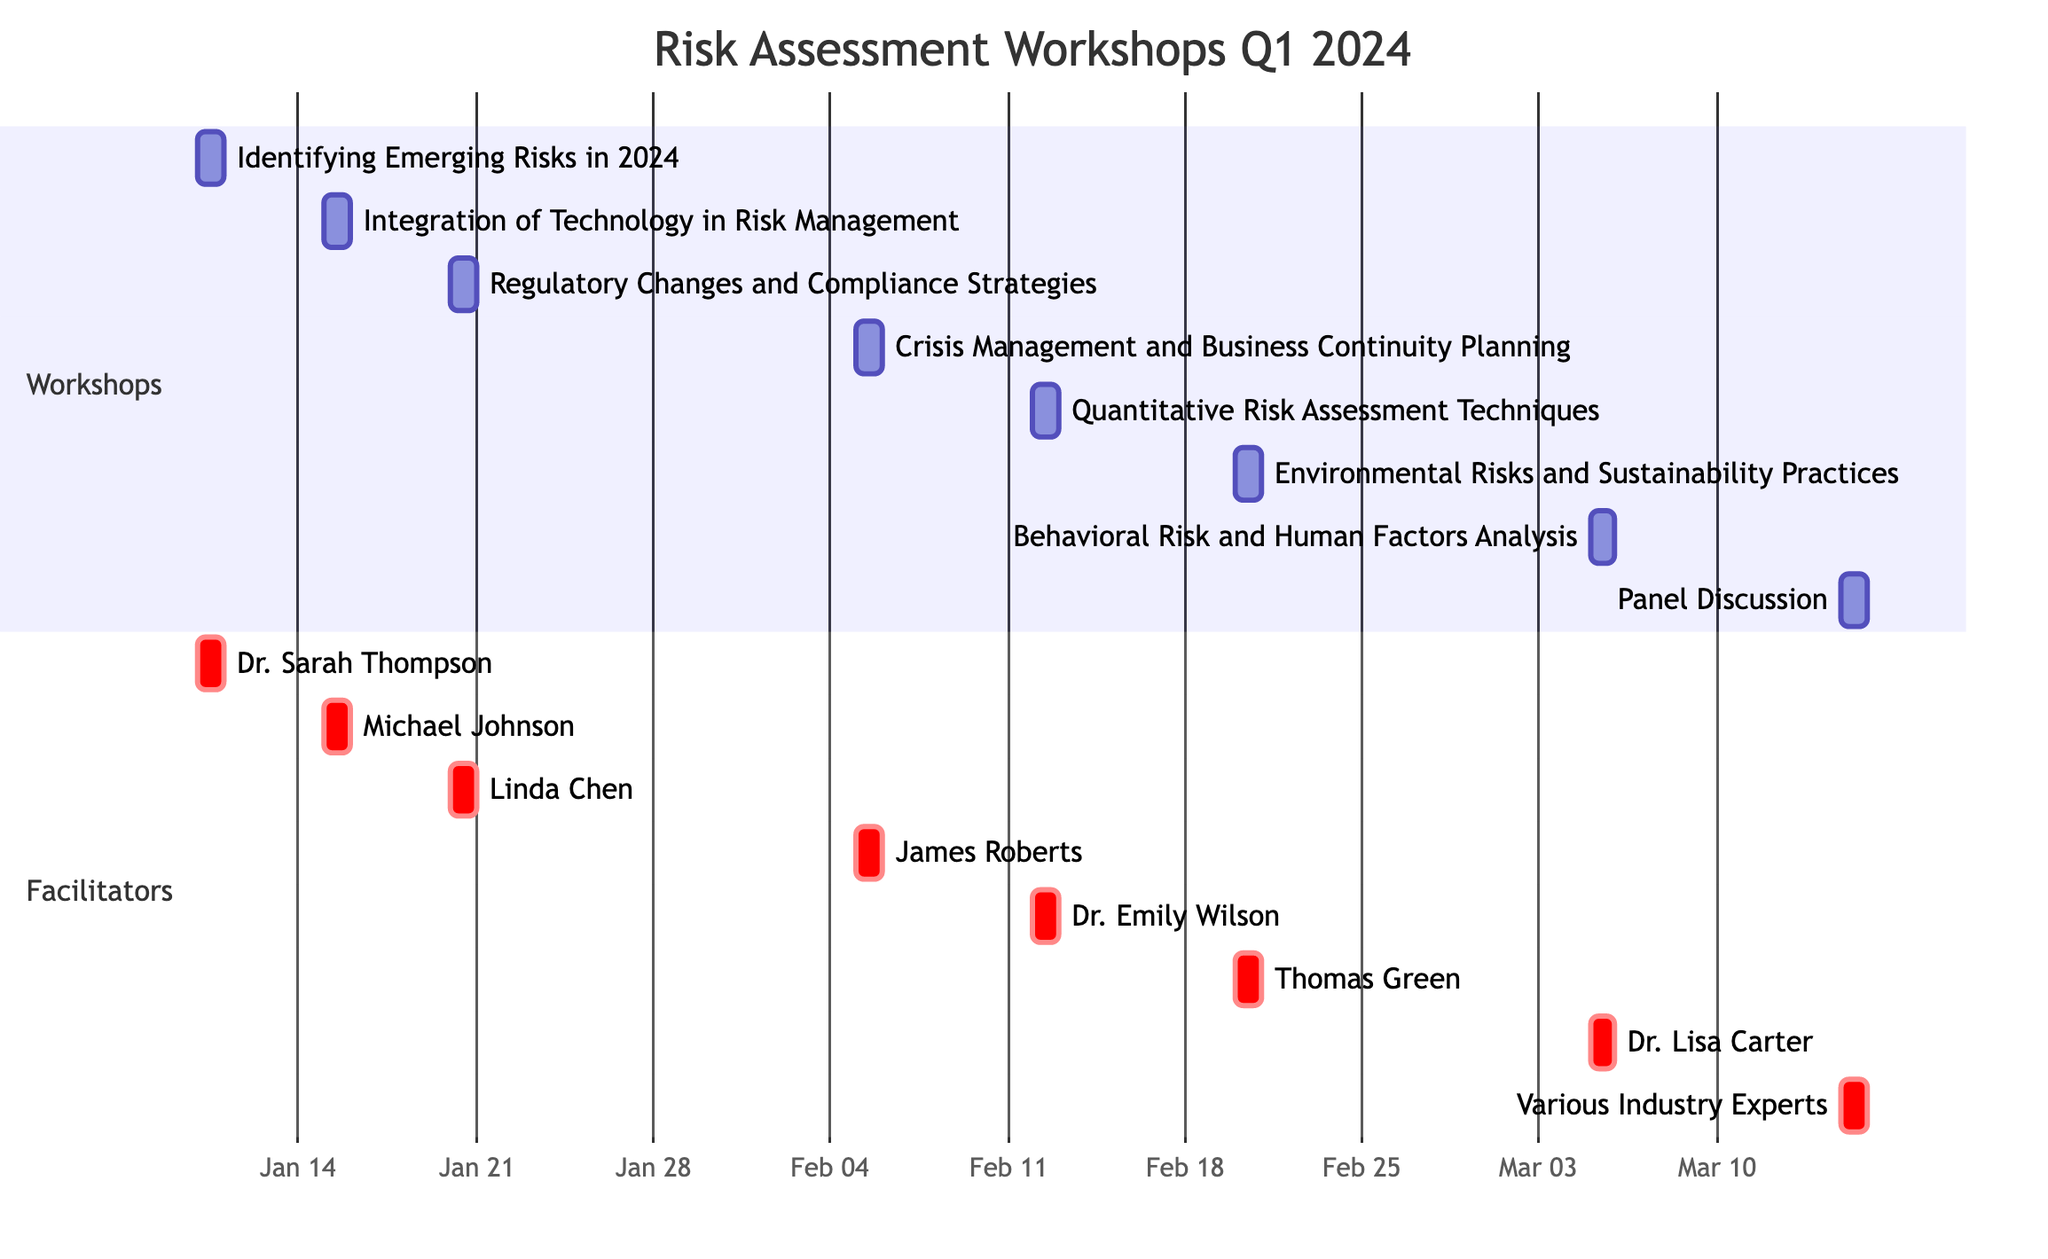What is the title of the first workshop scheduled in January? The first workshop is titled "Identifying Emerging Risks in 2024," which is on January 10th.
Answer: Identifying Emerging Risks in 2024 Who is the facilitator for the workshop on February 20? The workshop scheduled for February 20 is titled "Environmental Risks and Sustainability Practices," and it is facilitated by Thomas Green.
Answer: Thomas Green How many workshops are scheduled in March? In March, there are two workshops. The titles are "Behavioral Risk and Human Factors Analysis" on March 5th and "Panel Discussion: Future Trends in Risk Management" on March 15th.
Answer: 2 What is the start date of the workshop on quantitative risk assessment? The workshop titled "Quantitative Risk Assessment Techniques" starts on February 12, 2024.
Answer: February 12 Which facilitator is leading the workshop on crisis management? The workshop on February 5, titled "Crisis Management and Business Continuity Planning," is facilitated by James Roberts.
Answer: James Roberts How many total workshops are planned for Q1 2024? There are a total of eight workshops scheduled for Q1 2024, from January to March.
Answer: 8 What topic is covered in the workshop facilitated by Dr. Lisa Carter? Dr. Lisa Carter is facilitating the workshop titled "Behavioral Risk and Human Factors Analysis," which is scheduled for March 5.
Answer: Behavioral Risk and Human Factors Analysis Is there a workshop focusing on regulatory changes? Yes, there is a workshop titled "Regulatory Changes and Compliance Strategies," scheduled for January 20.
Answer: Yes What date marks the last workshop planned in the Gantt chart? The last workshop is on March 15, 2024, titled "Panel Discussion: Future Trends in Risk Management."
Answer: March 15 